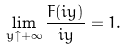<formula> <loc_0><loc_0><loc_500><loc_500>\lim _ { y \uparrow + \infty } \frac { F ( i y ) } { i y } = 1 .</formula> 